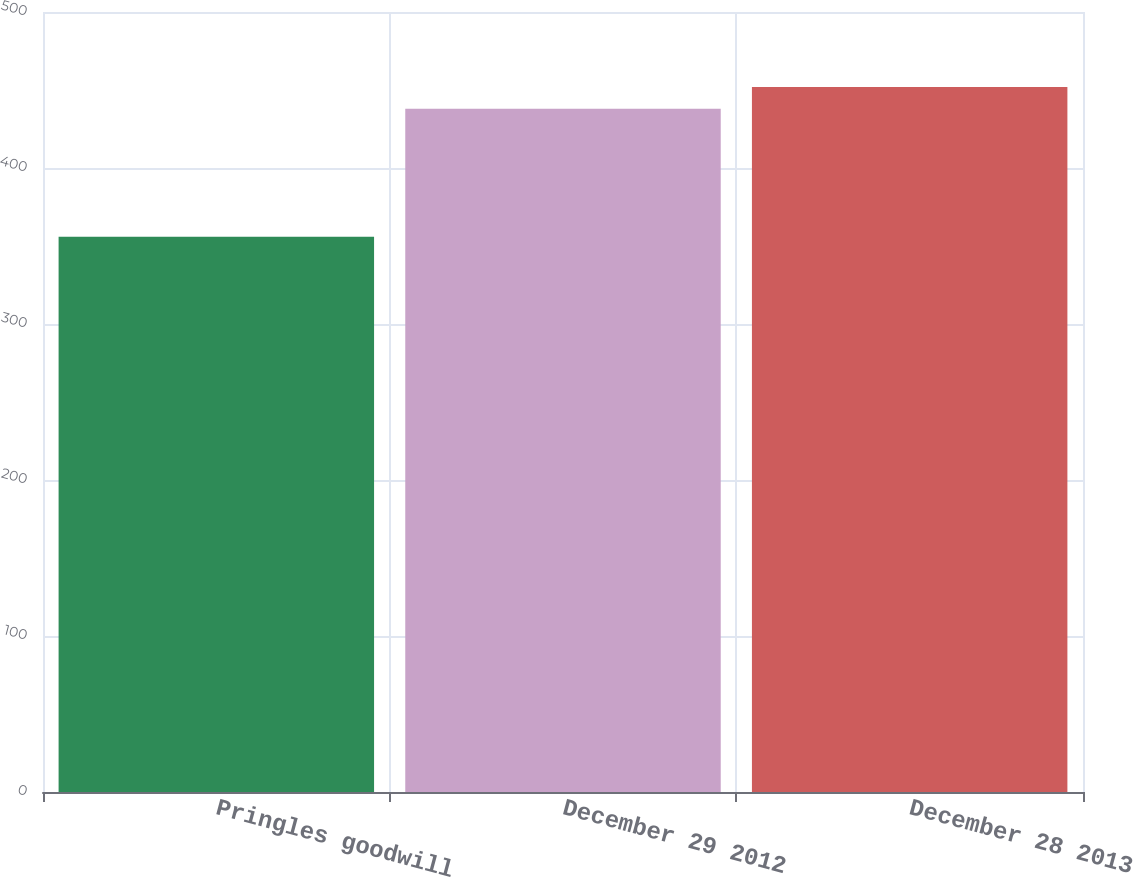Convert chart. <chart><loc_0><loc_0><loc_500><loc_500><bar_chart><fcel>Pringles goodwill<fcel>December 29 2012<fcel>December 28 2013<nl><fcel>356<fcel>438<fcel>452<nl></chart> 